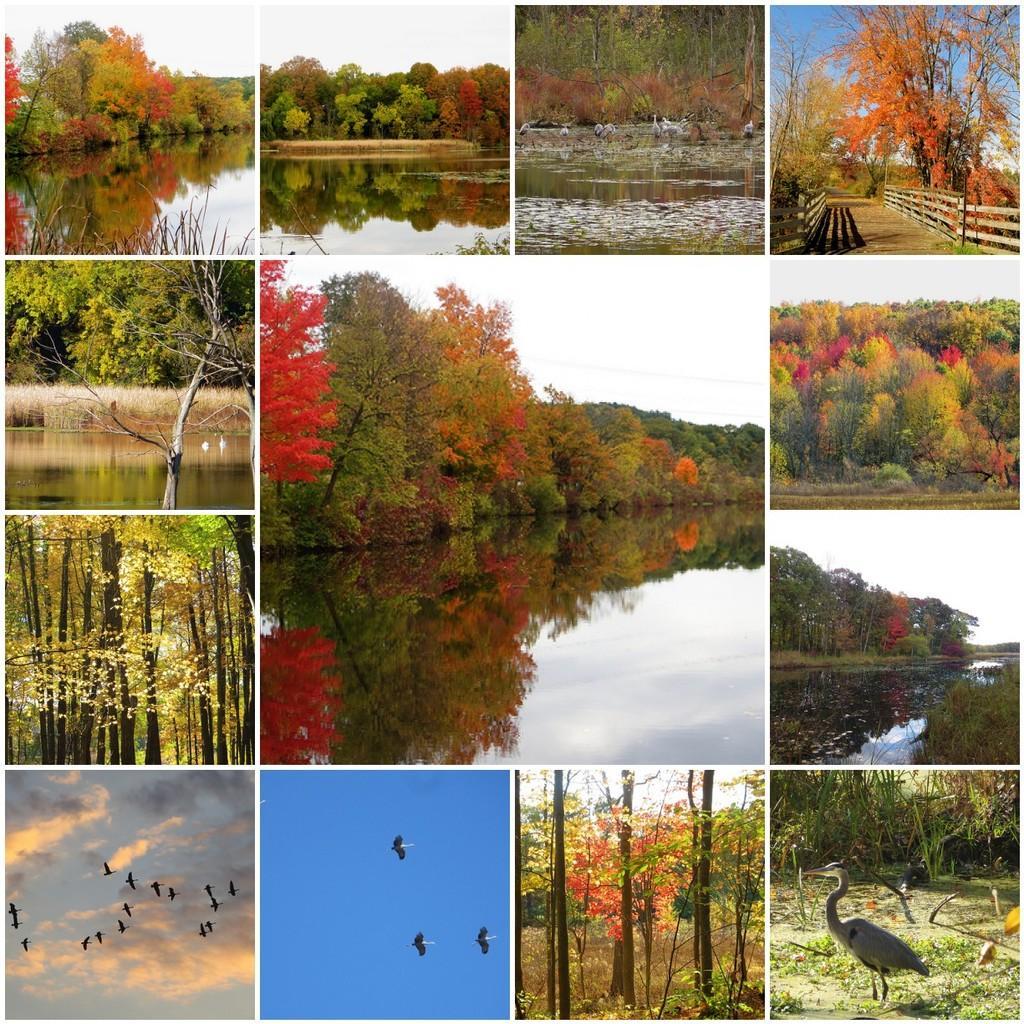How would you summarize this image in a sentence or two? The picture is a collage. At the bottom there are birds and trees. In the center of the picture there are trees and water. At the top, in the pictures there are trees, water and railing. 